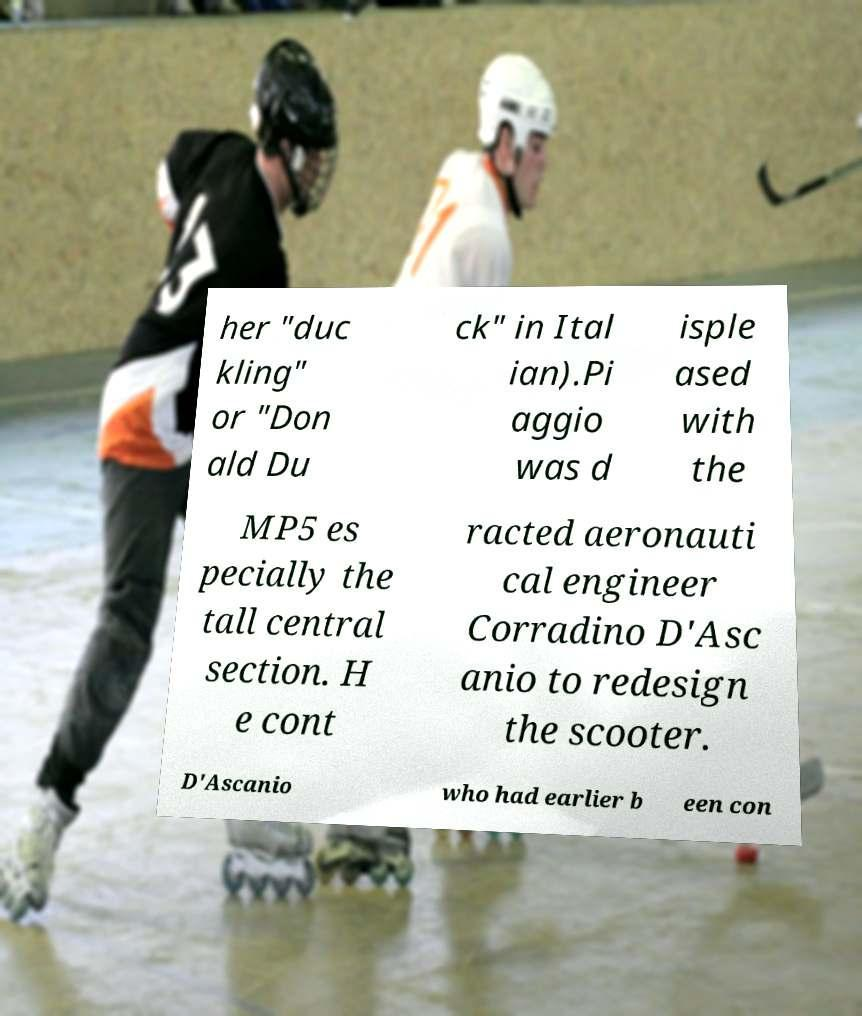Can you accurately transcribe the text from the provided image for me? her "duc kling" or "Don ald Du ck" in Ital ian).Pi aggio was d isple ased with the MP5 es pecially the tall central section. H e cont racted aeronauti cal engineer Corradino D'Asc anio to redesign the scooter. D'Ascanio who had earlier b een con 